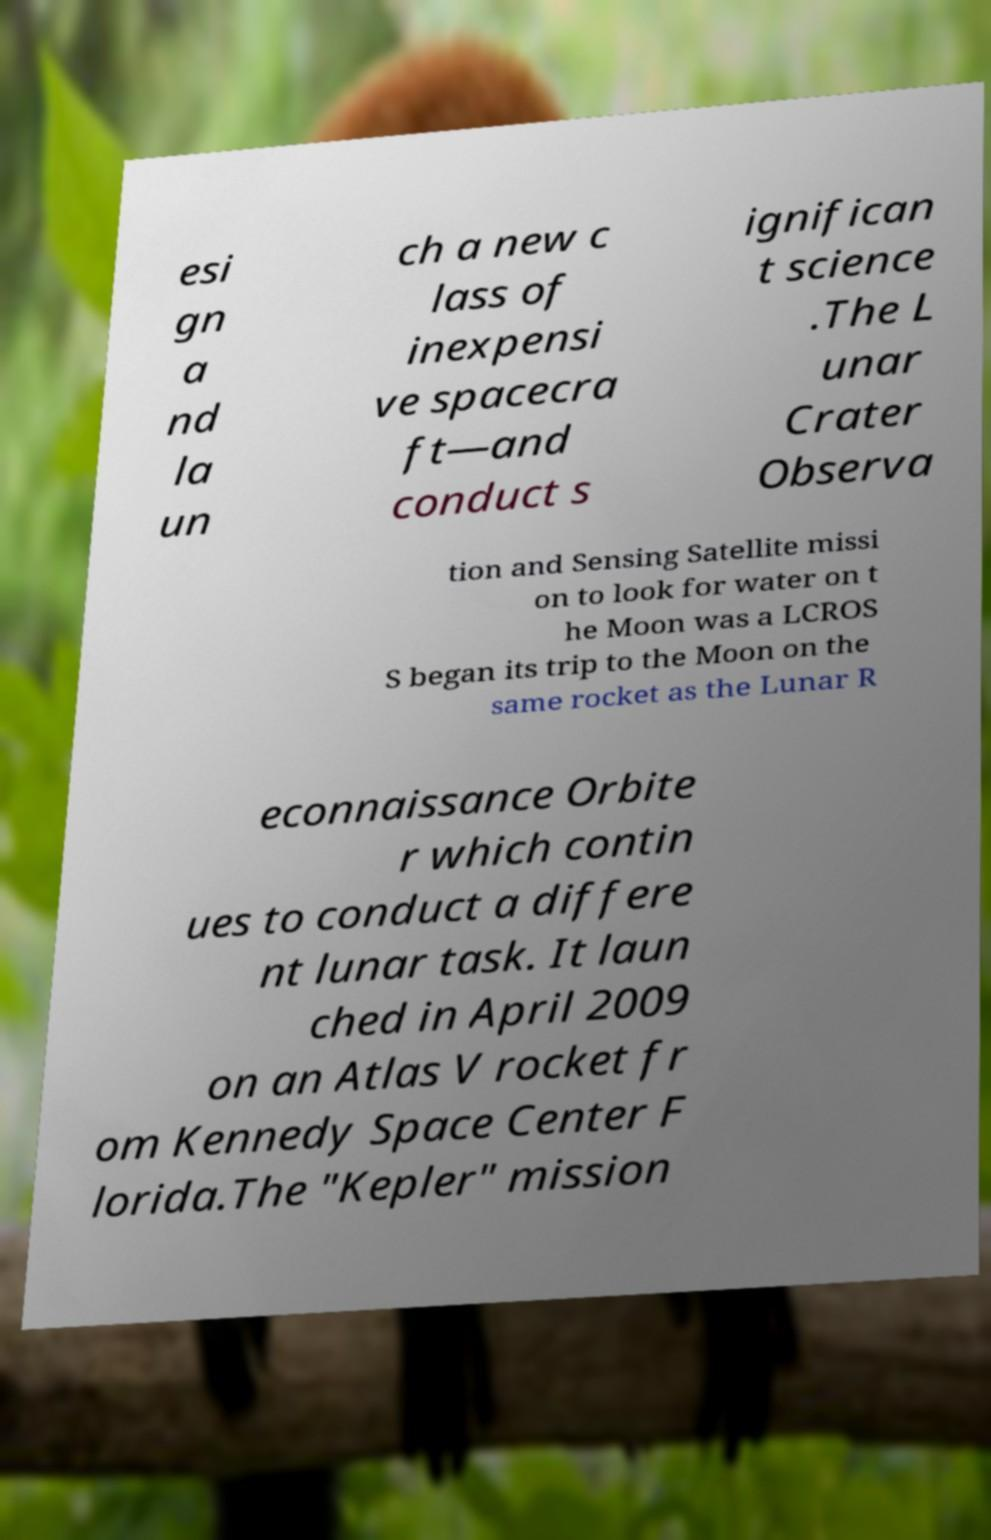Can you accurately transcribe the text from the provided image for me? esi gn a nd la un ch a new c lass of inexpensi ve spacecra ft—and conduct s ignifican t science .The L unar Crater Observa tion and Sensing Satellite missi on to look for water on t he Moon was a LCROS S began its trip to the Moon on the same rocket as the Lunar R econnaissance Orbite r which contin ues to conduct a differe nt lunar task. It laun ched in April 2009 on an Atlas V rocket fr om Kennedy Space Center F lorida.The "Kepler" mission 